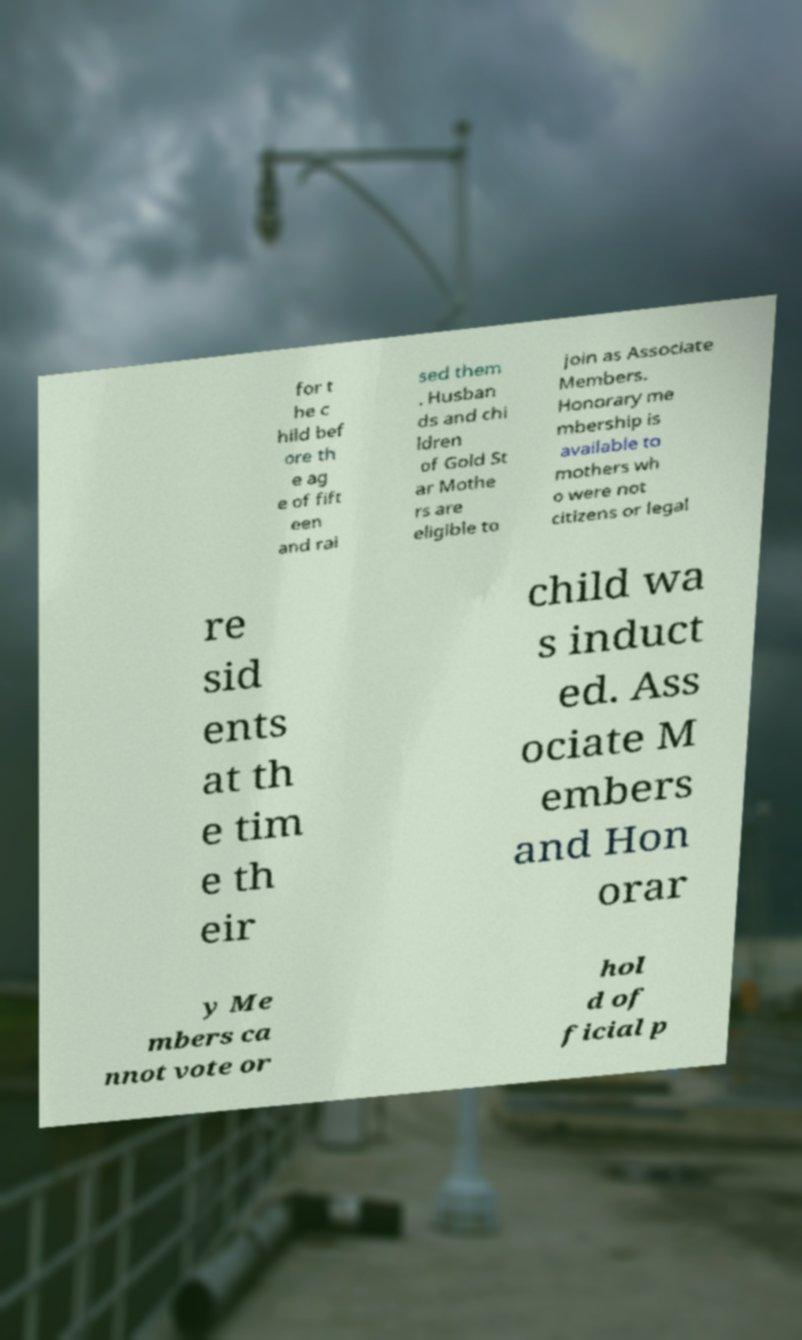Could you extract and type out the text from this image? for t he c hild bef ore th e ag e of fift een and rai sed them . Husban ds and chi ldren of Gold St ar Mothe rs are eligible to join as Associate Members. Honorary me mbership is available to mothers wh o were not citizens or legal re sid ents at th e tim e th eir child wa s induct ed. Ass ociate M embers and Hon orar y Me mbers ca nnot vote or hol d of ficial p 